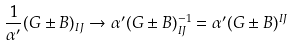<formula> <loc_0><loc_0><loc_500><loc_500>\frac { 1 } { \alpha ^ { \prime } } ( G \pm B ) _ { I J } \rightarrow \alpha ^ { \prime } ( G \pm B ) _ { I J } ^ { - 1 } = \alpha ^ { \prime } ( G \pm B ) ^ { I J }</formula> 